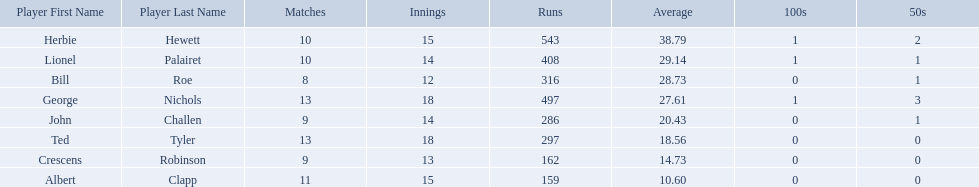Who are all of the players? Herbie Hewett, Lionel Palairet, Bill Roe, George Nichols, John Challen, Ted Tyler, Crescens Robinson, Albert Clapp. How many innings did they play in? 15, 14, 12, 18, 14, 18, 13, 15. Which player was in fewer than 13 innings? Bill Roe. Which players played in 10 or fewer matches? Herbie Hewett, Lionel Palairet, Bill Roe, John Challen, Crescens Robinson. Of these, which played in only 12 innings? Bill Roe. 